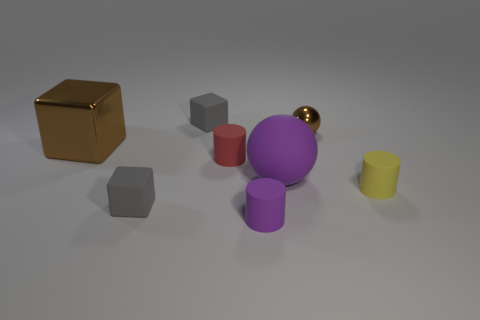Is the small metal ball the same color as the metallic block?
Keep it short and to the point. Yes. The small gray thing to the left of the tiny gray rubber cube that is behind the large purple object is made of what material?
Your answer should be compact. Rubber. Is there a tiny gray thing made of the same material as the purple cylinder?
Provide a succinct answer. Yes. There is a big metal thing left of the gray matte thing that is in front of the small rubber cylinder left of the small purple rubber thing; what shape is it?
Keep it short and to the point. Cube. What is the small brown object made of?
Provide a short and direct response. Metal. What is the color of the sphere that is made of the same material as the big cube?
Ensure brevity in your answer.  Brown. There is a matte object that is right of the purple ball; are there any matte cylinders in front of it?
Make the answer very short. Yes. What number of other things are there of the same shape as the small red matte object?
Your answer should be very brief. 2. Does the small gray object that is in front of the yellow matte cylinder have the same shape as the small gray object behind the yellow thing?
Your response must be concise. Yes. There is a purple matte sphere on the left side of the ball right of the big rubber thing; what number of blocks are in front of it?
Provide a succinct answer. 1. 